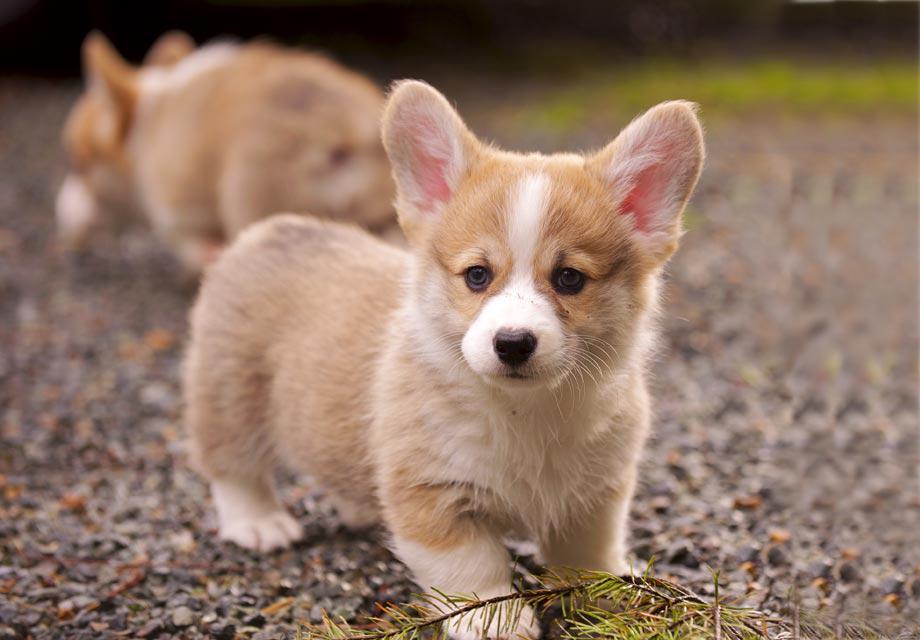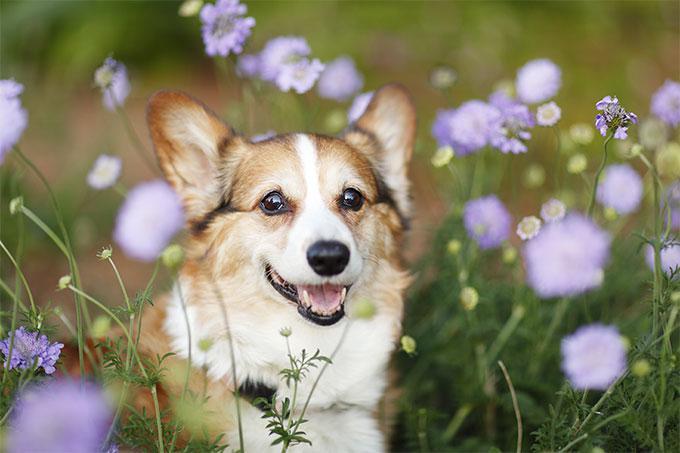The first image is the image on the left, the second image is the image on the right. Analyze the images presented: Is the assertion "The image on the right shows a corgi puppy in the middle of a grassy area with flowers." valid? Answer yes or no. Yes. The first image is the image on the left, the second image is the image on the right. Given the left and right images, does the statement "In the image on the right, a dog rests among some flowers." hold true? Answer yes or no. Yes. 